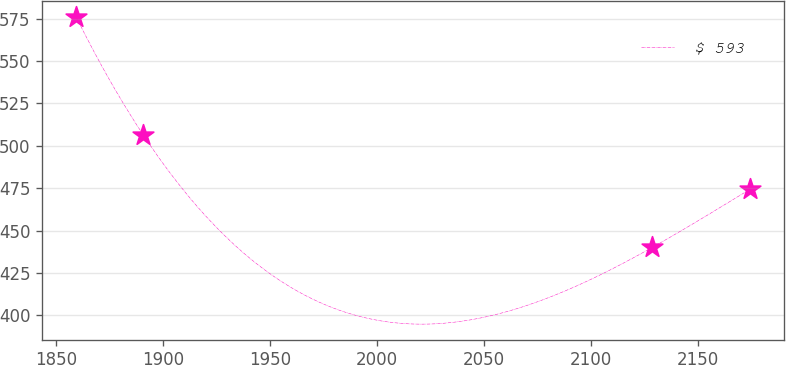Convert chart. <chart><loc_0><loc_0><loc_500><loc_500><line_chart><ecel><fcel>$ 593<nl><fcel>1859.13<fcel>576.21<nl><fcel>1890.67<fcel>506.33<nl><fcel>2128.77<fcel>440.19<nl><fcel>2174.48<fcel>474.48<nl></chart> 